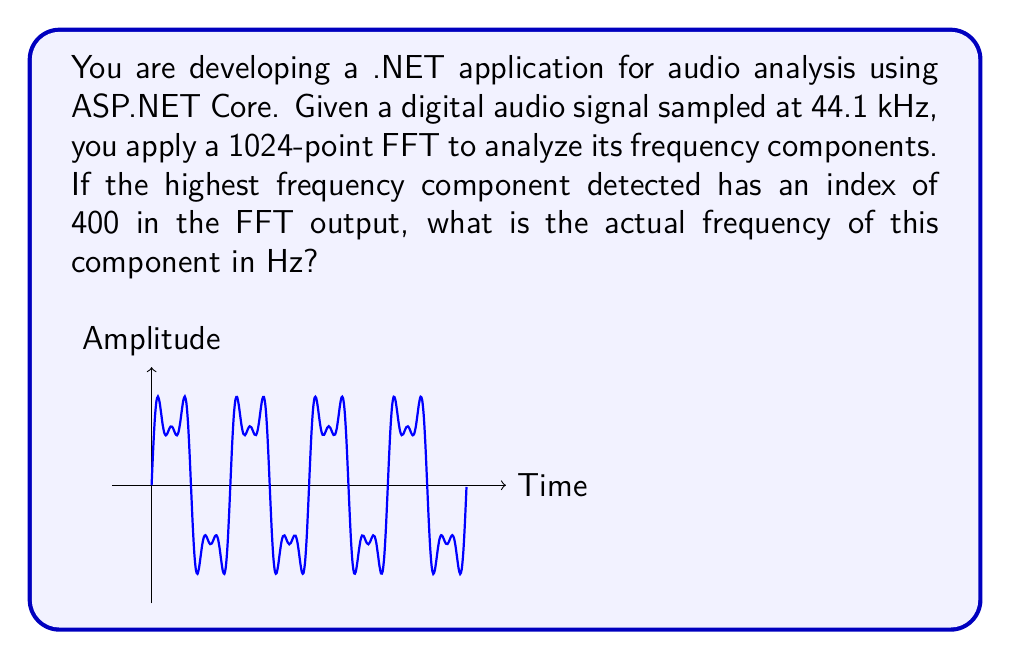Can you answer this question? Let's approach this step-by-step:

1) In the FFT output, the index corresponds to the frequency bin. The relationship between the index and the actual frequency is:

   $$ f = \frac{k \cdot f_s}{N} $$

   Where:
   $f$ is the actual frequency
   $k$ is the index in the FFT output
   $f_s$ is the sampling rate
   $N$ is the number of points in the FFT

2) We are given:
   - Sampling rate, $f_s = 44.1$ kHz = $44100$ Hz
   - Number of FFT points, $N = 1024$
   - Index of the highest frequency component, $k = 400$

3) Substituting these values into the equation:

   $$ f = \frac{400 \cdot 44100}{1024} $$

4) Simplifying:
   $$ f = \frac{17640000}{1024} = 17226.5625 \text{ Hz} $$

5) Rounding to a reasonable precision for audio applications:

   $$ f \approx 17226.6 \text{ Hz} $$

This frequency falls within the audible range (generally considered to be 20 Hz to 20 kHz), which is consistent with typical audio signal analysis.
Answer: 17226.6 Hz 